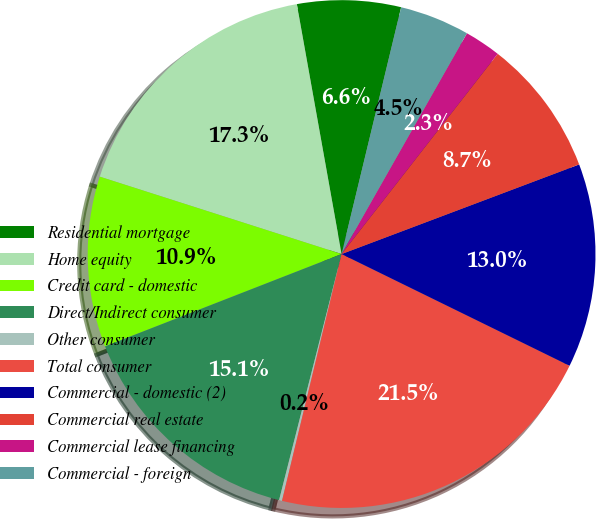<chart> <loc_0><loc_0><loc_500><loc_500><pie_chart><fcel>Residential mortgage<fcel>Home equity<fcel>Credit card - domestic<fcel>Direct/Indirect consumer<fcel>Other consumer<fcel>Total consumer<fcel>Commercial - domestic (2)<fcel>Commercial real estate<fcel>Commercial lease financing<fcel>Commercial - foreign<nl><fcel>6.59%<fcel>17.25%<fcel>10.85%<fcel>15.12%<fcel>0.19%<fcel>21.52%<fcel>12.99%<fcel>8.72%<fcel>2.32%<fcel>4.45%<nl></chart> 